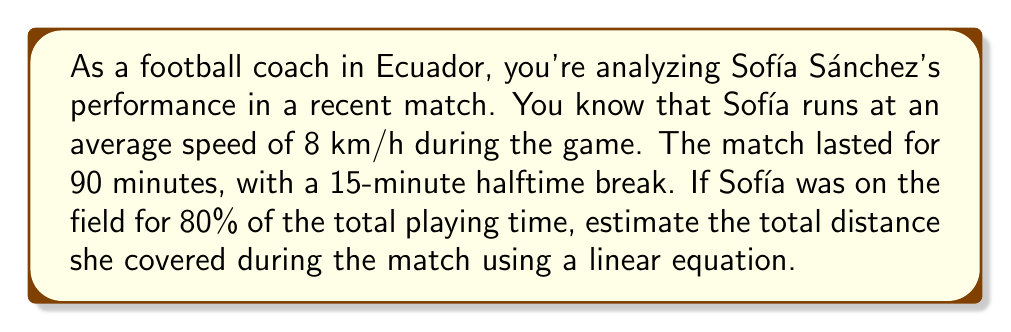What is the answer to this math problem? Let's approach this step-by-step:

1) First, let's calculate the total playing time:
   90 minutes - 15 minutes (halftime) = 75 minutes of actual playing time

2) Sofía was on the field for 80% of the playing time:
   $0.80 \times 75 \text{ minutes} = 60 \text{ minutes}$

3) Now, we can set up a linear equation to represent the distance covered:
   Let $d$ be the distance covered in kilometers
   Let $t$ be the time in hours

   The linear equation is: $d = 8t$ (since speed = distance/time)

4) We need to convert 60 minutes to hours:
   $60 \text{ minutes} = 1 \text{ hour}$

5) Now we can plug this into our equation:
   $d = 8 \times 1 = 8 \text{ km}$

Therefore, we can estimate that Sofía Sánchez covered approximately 8 km during the match.
Answer: $8 \text{ km}$ 